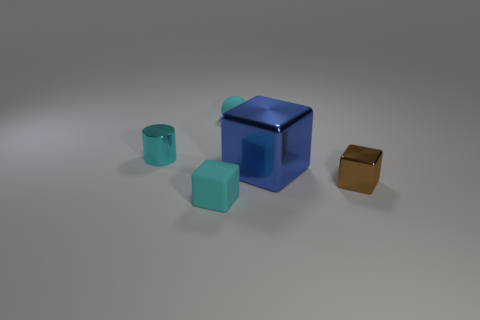Can you describe the arrangement of objects relative to the large blue block at the center? Certainly! At the center of the image rests a large blue block with a reflective surface, creating a striking focal point. To its right, there's a smaller cube with a similar finish but in a distinct golden hue, suggesting a metallic texture. On the left side, two smaller objects–one a cube and one a sphere–share a turquoise color, and they sit close to each other, radiating from the central block like satellites. 